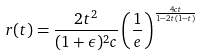Convert formula to latex. <formula><loc_0><loc_0><loc_500><loc_500>r ( t ) = \frac { 2 t ^ { 2 } } { ( 1 + \epsilon ) ^ { 2 } c } \left ( \frac { 1 } { e } \right ) ^ { \frac { 4 c t } { 1 - 2 t ( 1 - t ) } }</formula> 